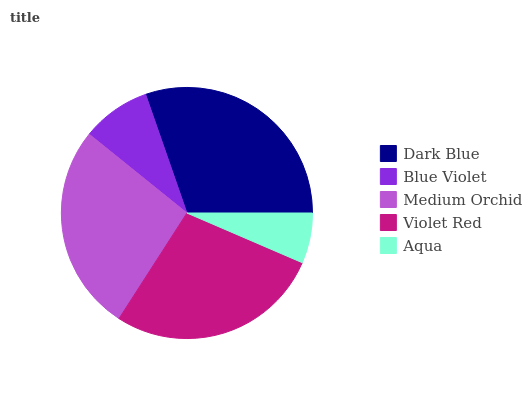Is Aqua the minimum?
Answer yes or no. Yes. Is Dark Blue the maximum?
Answer yes or no. Yes. Is Blue Violet the minimum?
Answer yes or no. No. Is Blue Violet the maximum?
Answer yes or no. No. Is Dark Blue greater than Blue Violet?
Answer yes or no. Yes. Is Blue Violet less than Dark Blue?
Answer yes or no. Yes. Is Blue Violet greater than Dark Blue?
Answer yes or no. No. Is Dark Blue less than Blue Violet?
Answer yes or no. No. Is Medium Orchid the high median?
Answer yes or no. Yes. Is Medium Orchid the low median?
Answer yes or no. Yes. Is Violet Red the high median?
Answer yes or no. No. Is Blue Violet the low median?
Answer yes or no. No. 